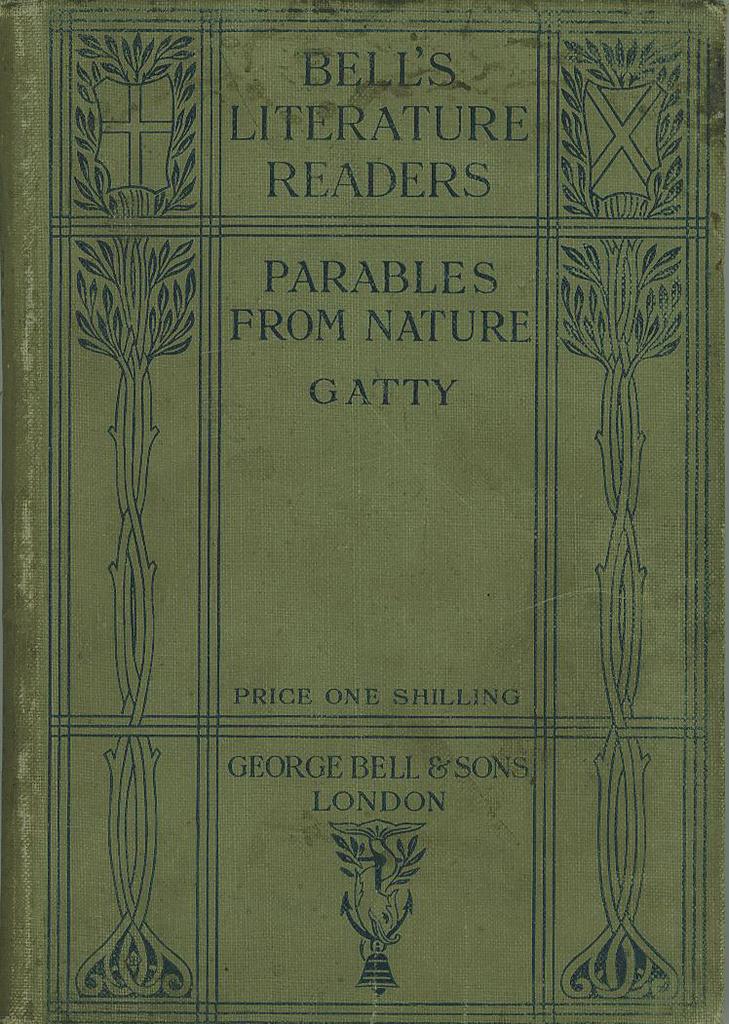How much is this book?
Offer a very short reply. One shilling. What kind of readers are mentioned at the top?
Offer a terse response. Bell's literature. 